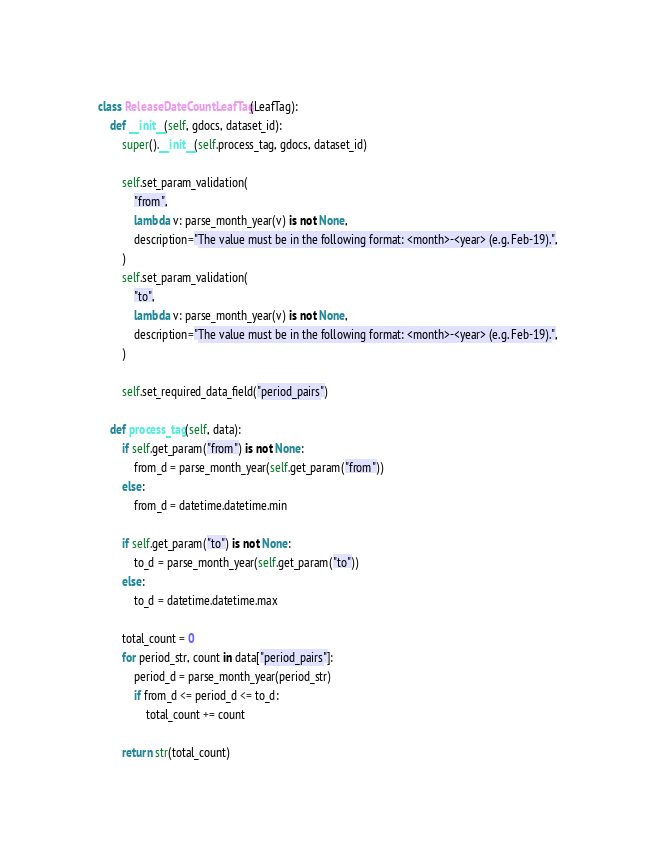Convert code to text. <code><loc_0><loc_0><loc_500><loc_500><_Python_>class ReleaseDateCountLeafTag(LeafTag):
    def __init__(self, gdocs, dataset_id):
        super().__init__(self.process_tag, gdocs, dataset_id)

        self.set_param_validation(
            "from",
            lambda v: parse_month_year(v) is not None,
            description="The value must be in the following format: <month>-<year> (e.g. Feb-19).",
        )
        self.set_param_validation(
            "to",
            lambda v: parse_month_year(v) is not None,
            description="The value must be in the following format: <month>-<year> (e.g. Feb-19).",
        )

        self.set_required_data_field("period_pairs")

    def process_tag(self, data):
        if self.get_param("from") is not None:
            from_d = parse_month_year(self.get_param("from"))
        else:
            from_d = datetime.datetime.min

        if self.get_param("to") is not None:
            to_d = parse_month_year(self.get_param("to"))
        else:
            to_d = datetime.datetime.max

        total_count = 0
        for period_str, count in data["period_pairs"]:
            period_d = parse_month_year(period_str)
            if from_d <= period_d <= to_d:
                total_count += count

        return str(total_count)
</code> 